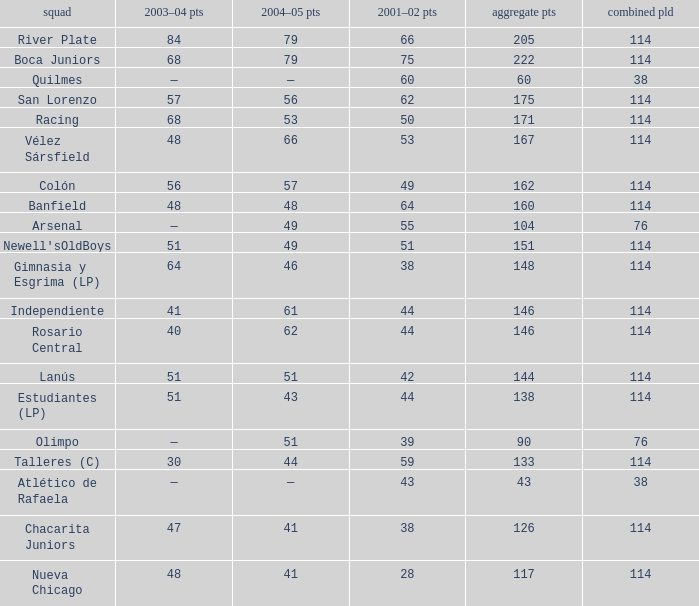Which Team has a Total Pld smaller than 114, and a 2004–05 Pts of 49? Arsenal. 